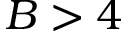Convert formula to latex. <formula><loc_0><loc_0><loc_500><loc_500>B > 4</formula> 